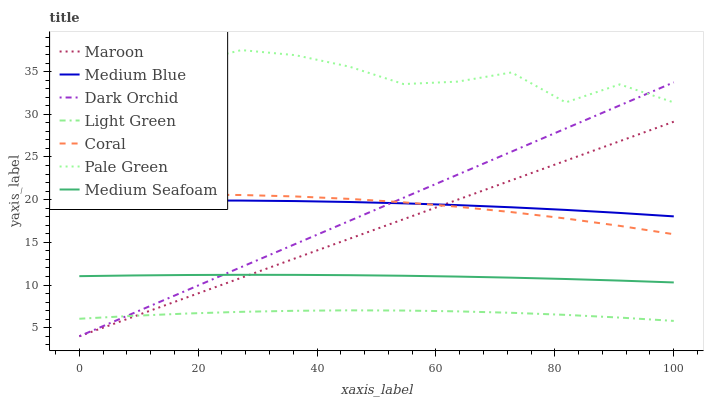Does Light Green have the minimum area under the curve?
Answer yes or no. Yes. Does Pale Green have the maximum area under the curve?
Answer yes or no. Yes. Does Medium Blue have the minimum area under the curve?
Answer yes or no. No. Does Medium Blue have the maximum area under the curve?
Answer yes or no. No. Is Maroon the smoothest?
Answer yes or no. Yes. Is Pale Green the roughest?
Answer yes or no. Yes. Is Medium Blue the smoothest?
Answer yes or no. No. Is Medium Blue the roughest?
Answer yes or no. No. Does Dark Orchid have the lowest value?
Answer yes or no. Yes. Does Medium Blue have the lowest value?
Answer yes or no. No. Does Pale Green have the highest value?
Answer yes or no. Yes. Does Medium Blue have the highest value?
Answer yes or no. No. Is Light Green less than Pale Green?
Answer yes or no. Yes. Is Pale Green greater than Maroon?
Answer yes or no. Yes. Does Coral intersect Maroon?
Answer yes or no. Yes. Is Coral less than Maroon?
Answer yes or no. No. Is Coral greater than Maroon?
Answer yes or no. No. Does Light Green intersect Pale Green?
Answer yes or no. No. 